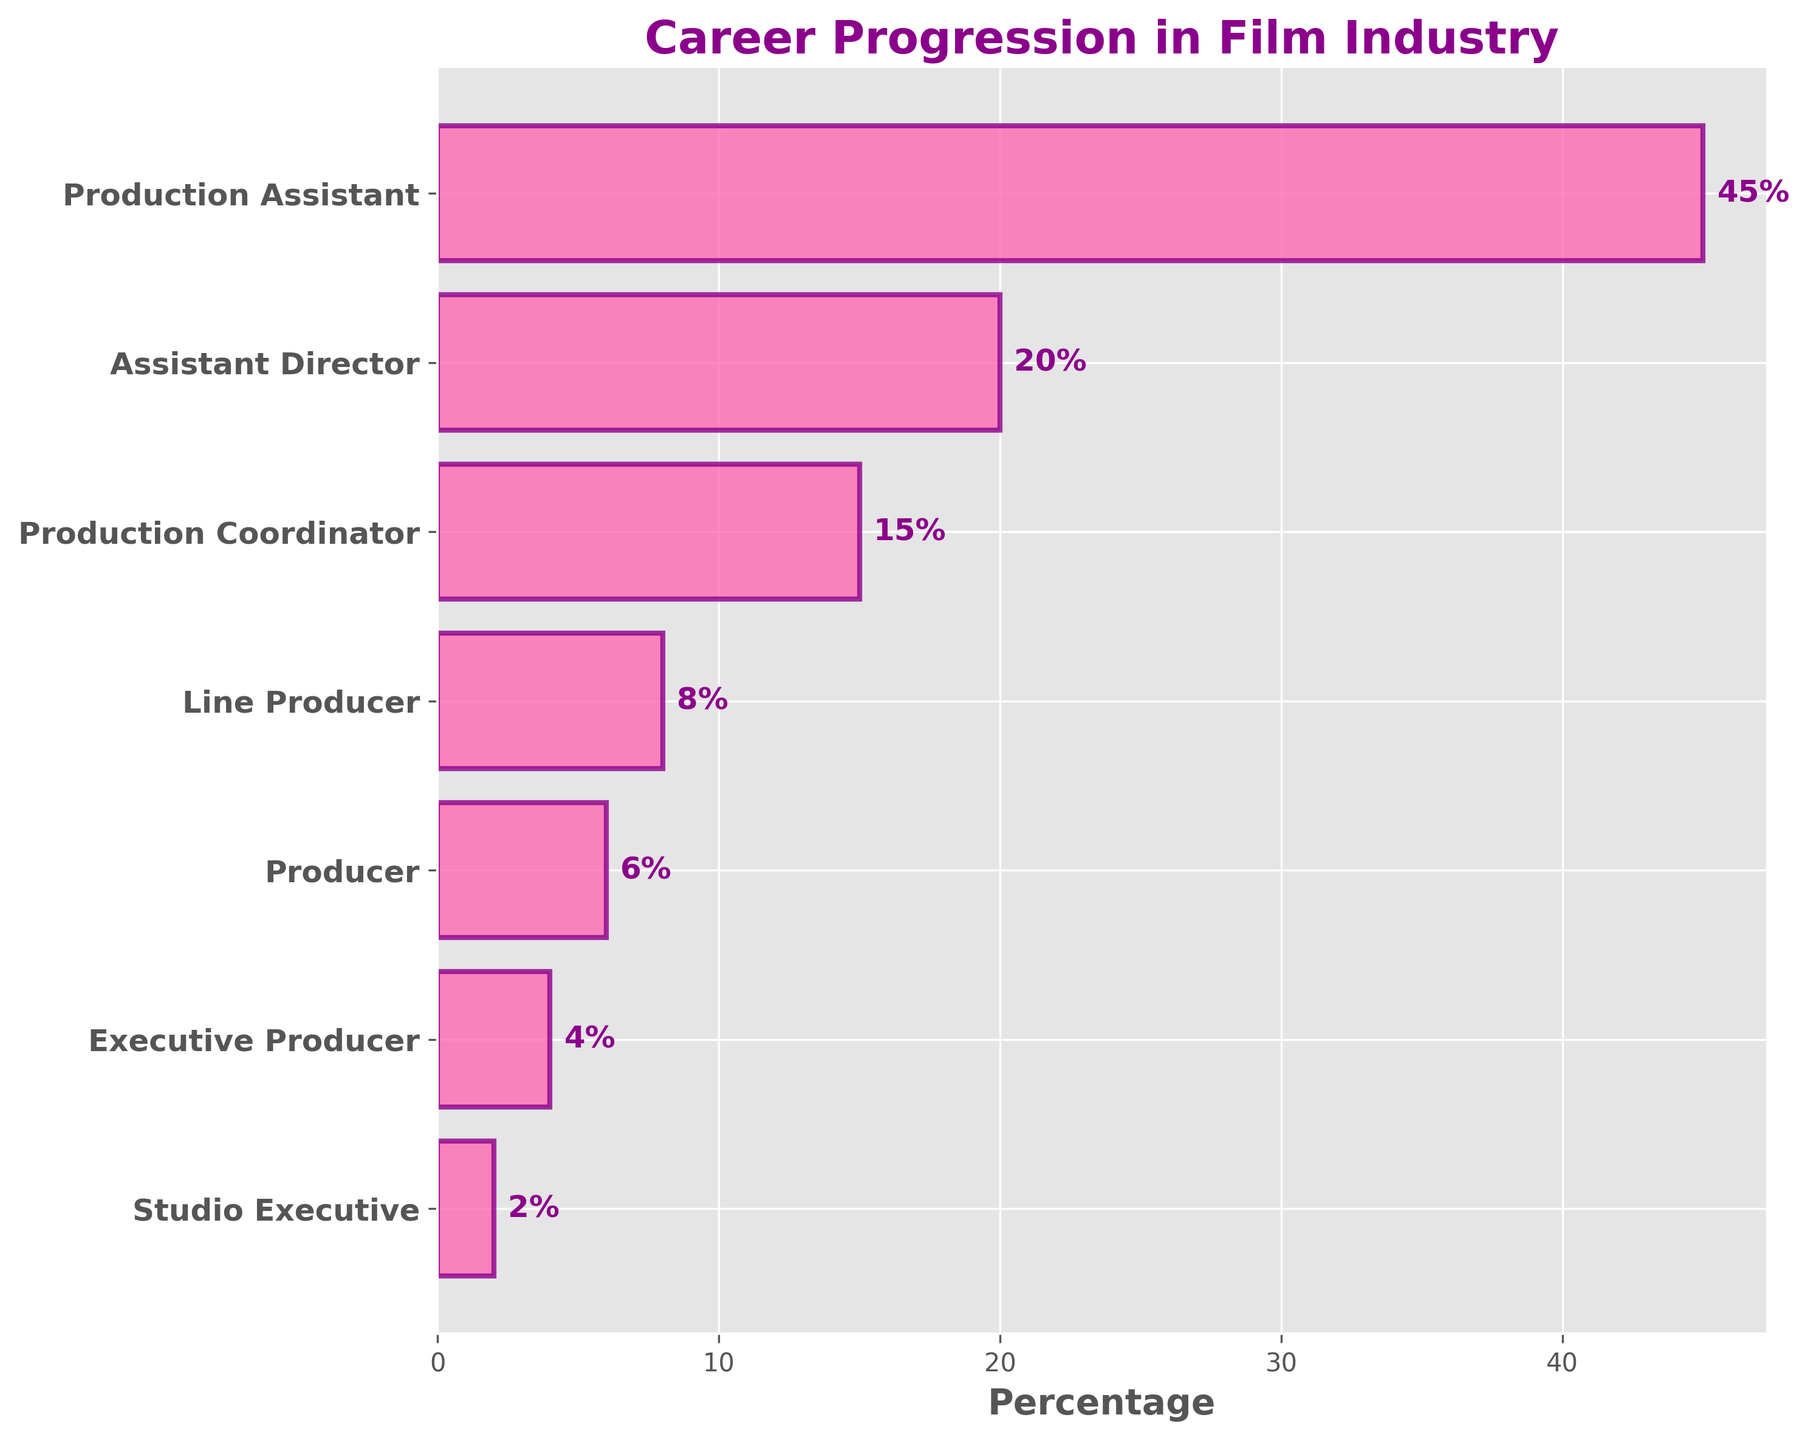What is the title of the chart? The title is displayed at the top of the chart, indicating the main focus of the visual representation, which is career progression in the film industry.
Answer: Career Progression in Film Industry What percentage of professionals are at the Assistant Director level? Identify the position labeled "Assistant Director," locate its corresponding bar, and read the percentage value written next to it.
Answer: 20% How many positions are represented in the chart? Count each of the positions listed on the y-axis to determine the total number of positions displayed.
Answer: 7 Which position has the highest percentage? The position with the longest bar on the chart represents the highest percentage. This can be identified as the position at the top of the funnel chart.
Answer: Production Assistant What is the difference in percentage between Production Coordinator and Executive Producer roles? Identify and note the percentages of Production Coordinator (15%) and Executive Producer (4%), then subtract the smaller percentage from the larger one: 15% - 4%.
Answer: 11% What percentage of professionals are in roles higher than Producer? Sum the percentages of the roles higher than Producer: Executive Producer (4%) + Studio Executive (2%).
Answer: 6% Is the percentage of Studio Executives greater or less than the percentage of Producers? Compare the percentage values next to "Studio Executive" (2%) with "Producer" (6%).
Answer: Less Which position has a lower percentage, Line Producer or Production Coordinator? Compare the percentages of Line Producer (8%) and Production Coordinator (15%) and determine which is smaller.
Answer: Line Producer What is the combined percentage of Production Assistants and Assistant Directors? Add the percentages of Production Assistant (45%) and Assistant Director (20%): 45% + 20%.
Answer: 65% Which category has the closest percentage to that of Line Producer? Identify the percentages for each position and determine that Line Producer is 8%, which is closest to Production Coordinator at 15%.
Answer: Production Coordinator 